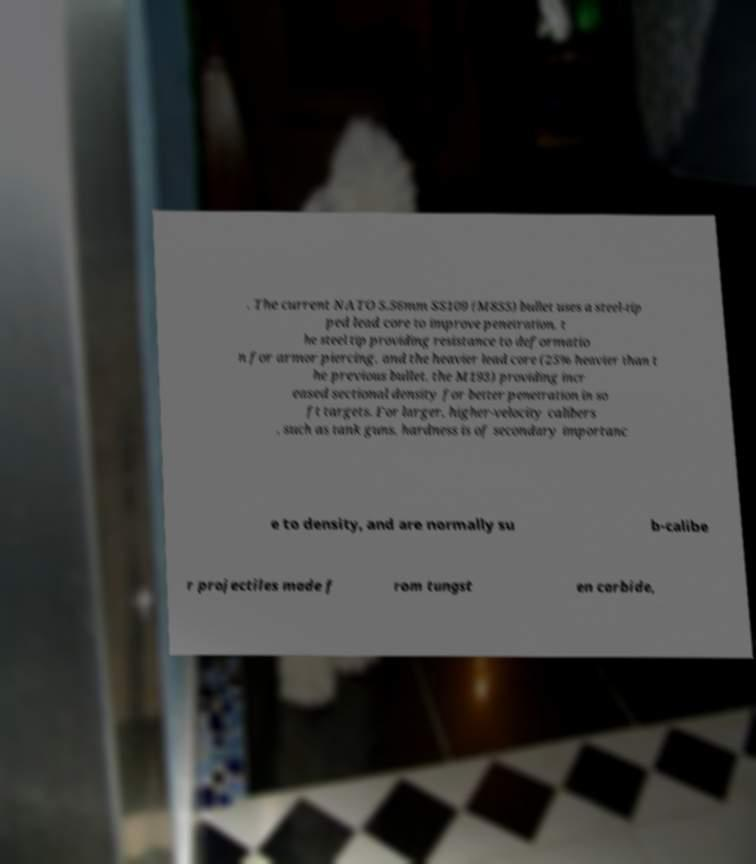Can you accurately transcribe the text from the provided image for me? . The current NATO 5.56mm SS109 (M855) bullet uses a steel-tip ped lead core to improve penetration, t he steel tip providing resistance to deformatio n for armor piercing, and the heavier lead core (25% heavier than t he previous bullet, the M193) providing incr eased sectional density for better penetration in so ft targets. For larger, higher-velocity calibers , such as tank guns, hardness is of secondary importanc e to density, and are normally su b-calibe r projectiles made f rom tungst en carbide, 